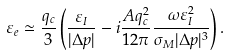Convert formula to latex. <formula><loc_0><loc_0><loc_500><loc_500>\varepsilon _ { e } \simeq \frac { q _ { c } } { 3 } \left ( \frac { \varepsilon _ { I } } { | \Delta p | } - i \frac { A q _ { c } ^ { 2 } } { 1 2 \pi } \frac { \omega \varepsilon _ { I } ^ { 2 } } { \sigma _ { M } | \Delta p | ^ { 3 } } \right ) .</formula> 